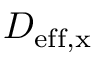<formula> <loc_0><loc_0><loc_500><loc_500>D _ { e f f , x }</formula> 